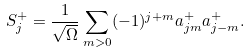Convert formula to latex. <formula><loc_0><loc_0><loc_500><loc_500>S ^ { + } _ { j } = \frac { 1 } { \sqrt { \Omega } } \sum _ { m > 0 } ( - 1 ) ^ { j + m } a ^ { + } _ { j m } a ^ { + } _ { j - m } .</formula> 